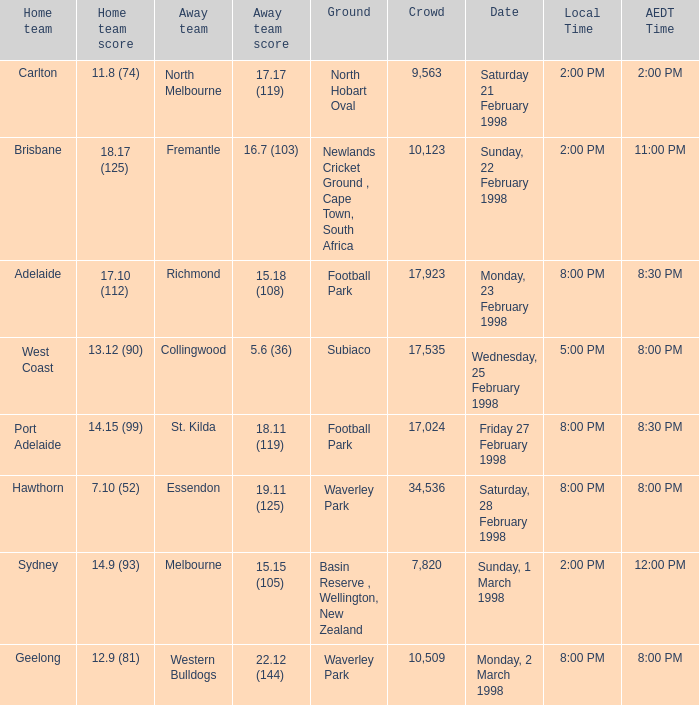Which Home team score has a AEDT Time of 11:00 pm? 18.17 (125). 